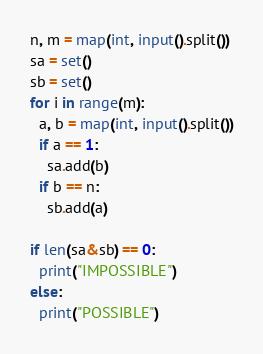Convert code to text. <code><loc_0><loc_0><loc_500><loc_500><_Python_>n, m = map(int, input().split())
sa = set()
sb = set()
for i in range(m):
  a, b = map(int, input().split())
  if a == 1:
    sa.add(b)
  if b == n:
    sb.add(a)

if len(sa&sb) == 0:
  print("IMPOSSIBLE")
else:
  print("POSSIBLE")  </code> 